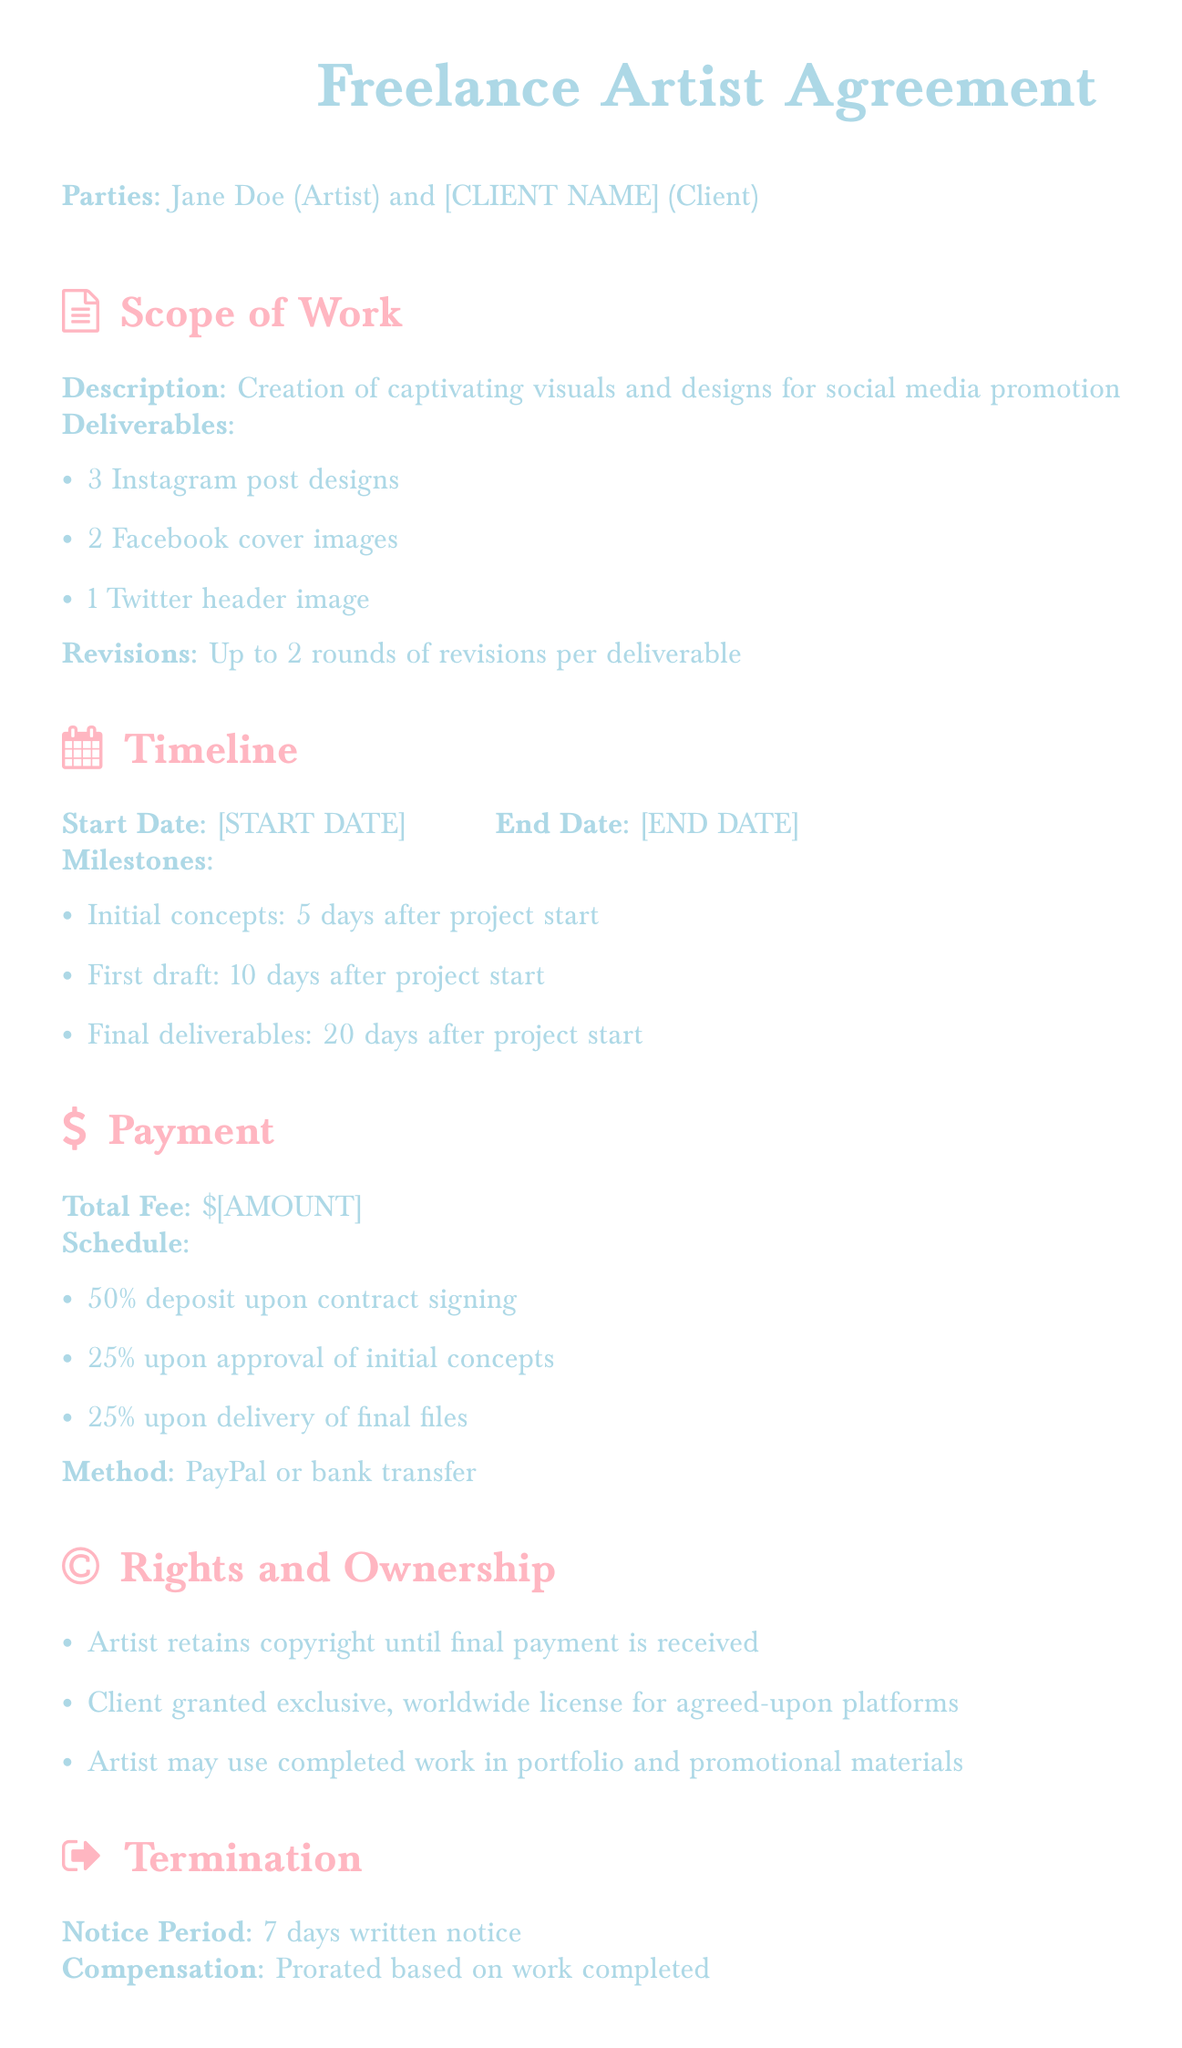What is the name of the artist? The document states the artist's name as Jane Doe.
Answer: Jane Doe What is the total fee for the project? The total fee amount is represented as \$[AMOUNT] in the document.
Answer: \$[AMOUNT] How many Instagram post designs are included in the deliverables? The document specifies that there are 3 Instagram post designs in the deliverables section.
Answer: 3 When is the final deliverable due? The timeline section indicates that the final deliverables are due 20 days after the project start.
Answer: 20 days after project start What percentage is required as a deposit upon contract signing? The payment schedule states that 50% is required as a deposit upon signing.
Answer: 50% What type of license is granted to the client? The rights section indicates that the client is granted an exclusive, worldwide license.
Answer: Exclusive, worldwide license How many revisions are included for each deliverable? The document states that there are up to 2 rounds of revisions per deliverable.
Answer: 2 rounds What is the notice period for termination? The termination section specifies that there is a 7 days written notice required for termination.
Answer: 7 days What payment methods are accepted? The payment section indicates that PayPal or bank transfer are the accepted methods.
Answer: PayPal or bank transfer 